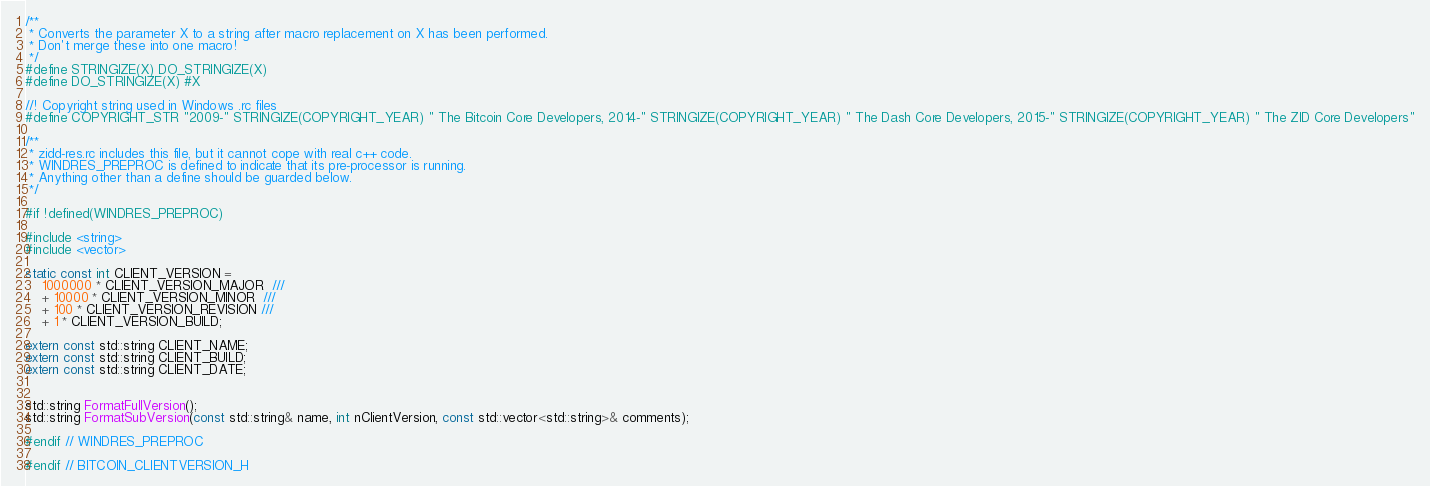<code> <loc_0><loc_0><loc_500><loc_500><_C_>/**
 * Converts the parameter X to a string after macro replacement on X has been performed.
 * Don't merge these into one macro!
 */
#define STRINGIZE(X) DO_STRINGIZE(X)
#define DO_STRINGIZE(X) #X

//! Copyright string used in Windows .rc files
#define COPYRIGHT_STR "2009-" STRINGIZE(COPYRIGHT_YEAR) " The Bitcoin Core Developers, 2014-" STRINGIZE(COPYRIGHT_YEAR) " The Dash Core Developers, 2015-" STRINGIZE(COPYRIGHT_YEAR) " The ZID Core Developers"

/**
 * zidd-res.rc includes this file, but it cannot cope with real c++ code.
 * WINDRES_PREPROC is defined to indicate that its pre-processor is running.
 * Anything other than a define should be guarded below.
 */

#if !defined(WINDRES_PREPROC)

#include <string>
#include <vector>

static const int CLIENT_VERSION =
    1000000 * CLIENT_VERSION_MAJOR  ///
    + 10000 * CLIENT_VERSION_MINOR  ///
    + 100 * CLIENT_VERSION_REVISION ///
    + 1 * CLIENT_VERSION_BUILD;

extern const std::string CLIENT_NAME;
extern const std::string CLIENT_BUILD;
extern const std::string CLIENT_DATE;


std::string FormatFullVersion();
std::string FormatSubVersion(const std::string& name, int nClientVersion, const std::vector<std::string>& comments);

#endif // WINDRES_PREPROC

#endif // BITCOIN_CLIENTVERSION_H
</code> 